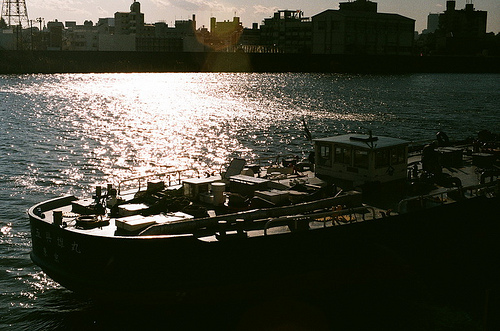Is there a bridge in this photo? There isn't a clear, distinguishable bridge in the photo, though there are distant structures that could be part of waterfront infrastructure. 